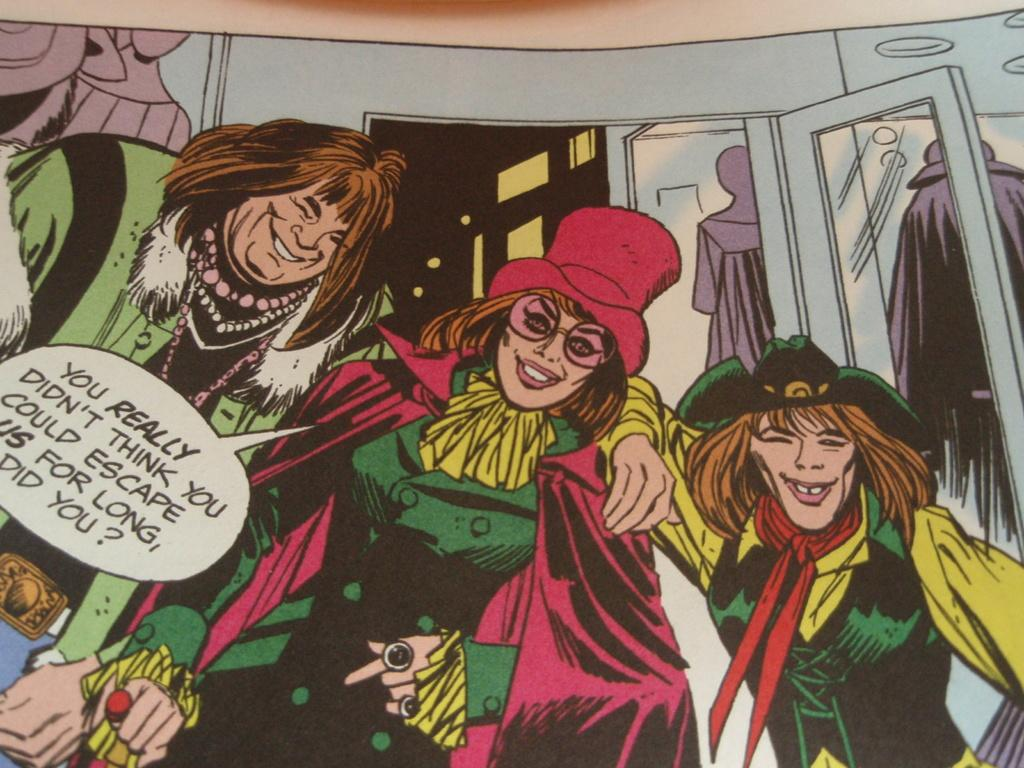What types of images are present in the picture? There are different animated images in the picture. Can you describe any text or writing in the picture? Yes, there is a note written on the left side of the picture. What type of ornament is hanging from the camera in the image? There is no camera present in the image, so it is not possible to determine if there is an ornament hanging from it. 